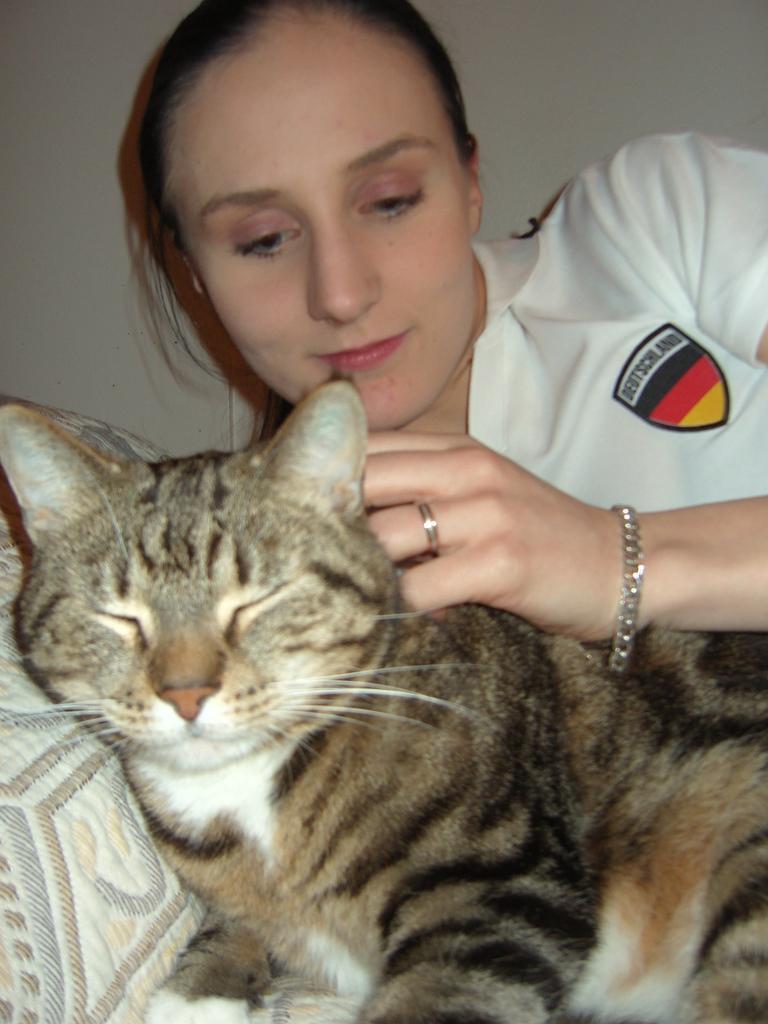Could you give a brief overview of what you see in this image? In this image we can see a cat is lying on a cloth and there is a woman. In the background we can see the wall. 